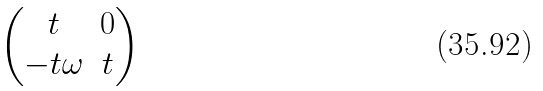Convert formula to latex. <formula><loc_0><loc_0><loc_500><loc_500>\begin{pmatrix} t & 0 \\ - t \omega & t \end{pmatrix}</formula> 